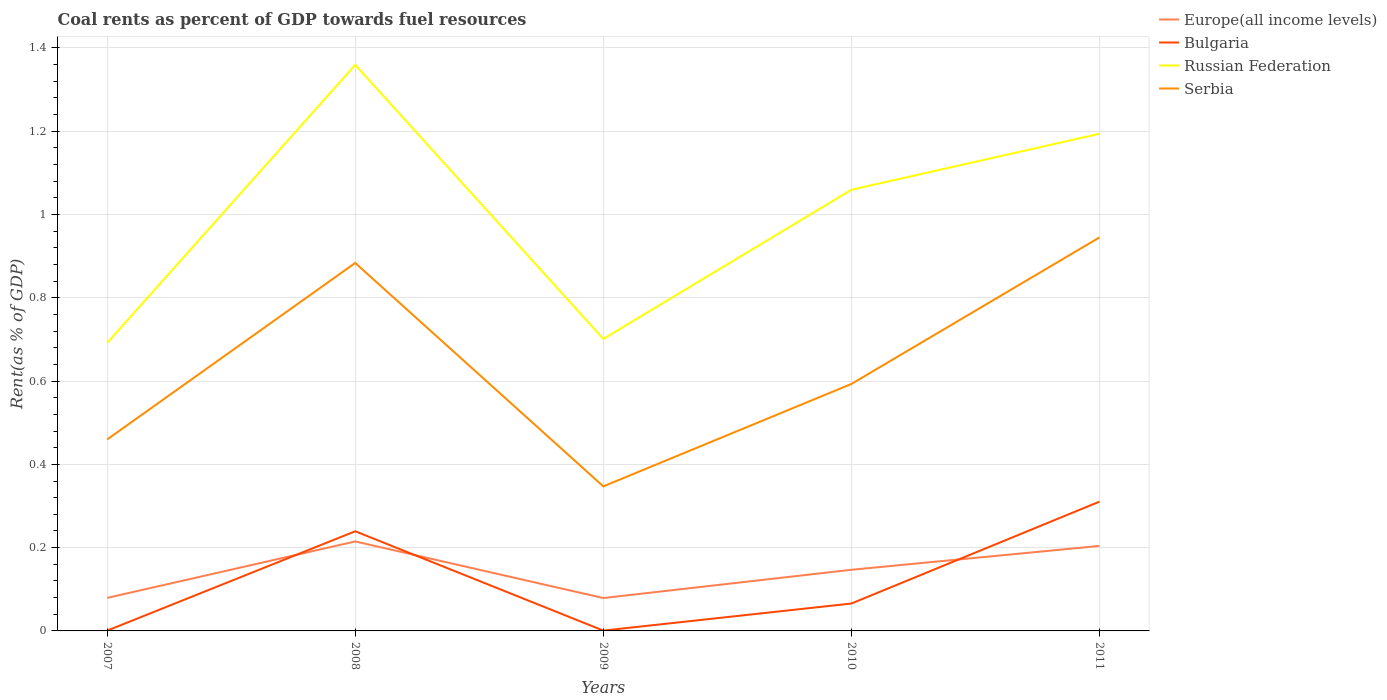How many different coloured lines are there?
Make the answer very short. 4. Is the number of lines equal to the number of legend labels?
Your response must be concise. Yes. Across all years, what is the maximum coal rent in Europe(all income levels)?
Your answer should be very brief. 0.08. In which year was the coal rent in Serbia maximum?
Offer a terse response. 2009. What is the total coal rent in Serbia in the graph?
Offer a very short reply. 0.29. What is the difference between the highest and the second highest coal rent in Serbia?
Provide a short and direct response. 0.6. Is the coal rent in Russian Federation strictly greater than the coal rent in Bulgaria over the years?
Make the answer very short. No. How many years are there in the graph?
Your response must be concise. 5. Are the values on the major ticks of Y-axis written in scientific E-notation?
Your response must be concise. No. Does the graph contain grids?
Keep it short and to the point. Yes. How are the legend labels stacked?
Offer a very short reply. Vertical. What is the title of the graph?
Give a very brief answer. Coal rents as percent of GDP towards fuel resources. Does "Maldives" appear as one of the legend labels in the graph?
Give a very brief answer. No. What is the label or title of the Y-axis?
Give a very brief answer. Rent(as % of GDP). What is the Rent(as % of GDP) in Europe(all income levels) in 2007?
Provide a short and direct response. 0.08. What is the Rent(as % of GDP) of Bulgaria in 2007?
Provide a short and direct response. 0. What is the Rent(as % of GDP) in Russian Federation in 2007?
Offer a terse response. 0.69. What is the Rent(as % of GDP) of Serbia in 2007?
Ensure brevity in your answer.  0.46. What is the Rent(as % of GDP) of Europe(all income levels) in 2008?
Provide a succinct answer. 0.21. What is the Rent(as % of GDP) of Bulgaria in 2008?
Provide a succinct answer. 0.24. What is the Rent(as % of GDP) of Russian Federation in 2008?
Provide a short and direct response. 1.36. What is the Rent(as % of GDP) of Serbia in 2008?
Your answer should be very brief. 0.88. What is the Rent(as % of GDP) of Europe(all income levels) in 2009?
Offer a terse response. 0.08. What is the Rent(as % of GDP) in Bulgaria in 2009?
Provide a succinct answer. 0. What is the Rent(as % of GDP) in Russian Federation in 2009?
Provide a short and direct response. 0.7. What is the Rent(as % of GDP) of Serbia in 2009?
Give a very brief answer. 0.35. What is the Rent(as % of GDP) in Europe(all income levels) in 2010?
Provide a short and direct response. 0.15. What is the Rent(as % of GDP) in Bulgaria in 2010?
Your response must be concise. 0.07. What is the Rent(as % of GDP) in Russian Federation in 2010?
Make the answer very short. 1.06. What is the Rent(as % of GDP) of Serbia in 2010?
Your answer should be compact. 0.59. What is the Rent(as % of GDP) in Europe(all income levels) in 2011?
Make the answer very short. 0.2. What is the Rent(as % of GDP) of Bulgaria in 2011?
Give a very brief answer. 0.31. What is the Rent(as % of GDP) of Russian Federation in 2011?
Your answer should be very brief. 1.19. What is the Rent(as % of GDP) of Serbia in 2011?
Provide a short and direct response. 0.94. Across all years, what is the maximum Rent(as % of GDP) of Europe(all income levels)?
Give a very brief answer. 0.21. Across all years, what is the maximum Rent(as % of GDP) of Bulgaria?
Ensure brevity in your answer.  0.31. Across all years, what is the maximum Rent(as % of GDP) of Russian Federation?
Your response must be concise. 1.36. Across all years, what is the maximum Rent(as % of GDP) of Serbia?
Provide a short and direct response. 0.94. Across all years, what is the minimum Rent(as % of GDP) in Europe(all income levels)?
Offer a very short reply. 0.08. Across all years, what is the minimum Rent(as % of GDP) of Bulgaria?
Your answer should be very brief. 0. Across all years, what is the minimum Rent(as % of GDP) of Russian Federation?
Keep it short and to the point. 0.69. Across all years, what is the minimum Rent(as % of GDP) of Serbia?
Provide a short and direct response. 0.35. What is the total Rent(as % of GDP) of Europe(all income levels) in the graph?
Give a very brief answer. 0.72. What is the total Rent(as % of GDP) of Bulgaria in the graph?
Your answer should be compact. 0.62. What is the total Rent(as % of GDP) of Russian Federation in the graph?
Your response must be concise. 5.01. What is the total Rent(as % of GDP) of Serbia in the graph?
Ensure brevity in your answer.  3.23. What is the difference between the Rent(as % of GDP) of Europe(all income levels) in 2007 and that in 2008?
Offer a very short reply. -0.14. What is the difference between the Rent(as % of GDP) of Bulgaria in 2007 and that in 2008?
Your response must be concise. -0.24. What is the difference between the Rent(as % of GDP) of Russian Federation in 2007 and that in 2008?
Your response must be concise. -0.67. What is the difference between the Rent(as % of GDP) of Serbia in 2007 and that in 2008?
Provide a short and direct response. -0.42. What is the difference between the Rent(as % of GDP) of Europe(all income levels) in 2007 and that in 2009?
Provide a short and direct response. 0. What is the difference between the Rent(as % of GDP) of Bulgaria in 2007 and that in 2009?
Give a very brief answer. -0. What is the difference between the Rent(as % of GDP) in Russian Federation in 2007 and that in 2009?
Your answer should be very brief. -0.01. What is the difference between the Rent(as % of GDP) in Serbia in 2007 and that in 2009?
Provide a succinct answer. 0.11. What is the difference between the Rent(as % of GDP) of Europe(all income levels) in 2007 and that in 2010?
Offer a very short reply. -0.07. What is the difference between the Rent(as % of GDP) of Bulgaria in 2007 and that in 2010?
Provide a short and direct response. -0.07. What is the difference between the Rent(as % of GDP) in Russian Federation in 2007 and that in 2010?
Keep it short and to the point. -0.37. What is the difference between the Rent(as % of GDP) in Serbia in 2007 and that in 2010?
Provide a succinct answer. -0.13. What is the difference between the Rent(as % of GDP) of Europe(all income levels) in 2007 and that in 2011?
Keep it short and to the point. -0.12. What is the difference between the Rent(as % of GDP) of Bulgaria in 2007 and that in 2011?
Make the answer very short. -0.31. What is the difference between the Rent(as % of GDP) in Russian Federation in 2007 and that in 2011?
Offer a terse response. -0.5. What is the difference between the Rent(as % of GDP) of Serbia in 2007 and that in 2011?
Keep it short and to the point. -0.49. What is the difference between the Rent(as % of GDP) of Europe(all income levels) in 2008 and that in 2009?
Offer a terse response. 0.14. What is the difference between the Rent(as % of GDP) in Bulgaria in 2008 and that in 2009?
Provide a succinct answer. 0.24. What is the difference between the Rent(as % of GDP) of Russian Federation in 2008 and that in 2009?
Make the answer very short. 0.66. What is the difference between the Rent(as % of GDP) in Serbia in 2008 and that in 2009?
Your response must be concise. 0.54. What is the difference between the Rent(as % of GDP) in Europe(all income levels) in 2008 and that in 2010?
Give a very brief answer. 0.07. What is the difference between the Rent(as % of GDP) of Bulgaria in 2008 and that in 2010?
Give a very brief answer. 0.17. What is the difference between the Rent(as % of GDP) in Serbia in 2008 and that in 2010?
Your answer should be compact. 0.29. What is the difference between the Rent(as % of GDP) of Europe(all income levels) in 2008 and that in 2011?
Keep it short and to the point. 0.01. What is the difference between the Rent(as % of GDP) in Bulgaria in 2008 and that in 2011?
Ensure brevity in your answer.  -0.07. What is the difference between the Rent(as % of GDP) of Russian Federation in 2008 and that in 2011?
Ensure brevity in your answer.  0.17. What is the difference between the Rent(as % of GDP) of Serbia in 2008 and that in 2011?
Provide a short and direct response. -0.06. What is the difference between the Rent(as % of GDP) of Europe(all income levels) in 2009 and that in 2010?
Offer a very short reply. -0.07. What is the difference between the Rent(as % of GDP) in Bulgaria in 2009 and that in 2010?
Give a very brief answer. -0.07. What is the difference between the Rent(as % of GDP) of Russian Federation in 2009 and that in 2010?
Provide a succinct answer. -0.36. What is the difference between the Rent(as % of GDP) of Serbia in 2009 and that in 2010?
Offer a very short reply. -0.25. What is the difference between the Rent(as % of GDP) in Europe(all income levels) in 2009 and that in 2011?
Offer a very short reply. -0.13. What is the difference between the Rent(as % of GDP) in Bulgaria in 2009 and that in 2011?
Provide a succinct answer. -0.31. What is the difference between the Rent(as % of GDP) in Russian Federation in 2009 and that in 2011?
Your response must be concise. -0.49. What is the difference between the Rent(as % of GDP) in Serbia in 2009 and that in 2011?
Your answer should be very brief. -0.6. What is the difference between the Rent(as % of GDP) of Europe(all income levels) in 2010 and that in 2011?
Make the answer very short. -0.06. What is the difference between the Rent(as % of GDP) in Bulgaria in 2010 and that in 2011?
Your answer should be compact. -0.24. What is the difference between the Rent(as % of GDP) of Russian Federation in 2010 and that in 2011?
Your answer should be very brief. -0.13. What is the difference between the Rent(as % of GDP) in Serbia in 2010 and that in 2011?
Make the answer very short. -0.35. What is the difference between the Rent(as % of GDP) of Europe(all income levels) in 2007 and the Rent(as % of GDP) of Bulgaria in 2008?
Make the answer very short. -0.16. What is the difference between the Rent(as % of GDP) in Europe(all income levels) in 2007 and the Rent(as % of GDP) in Russian Federation in 2008?
Provide a short and direct response. -1.28. What is the difference between the Rent(as % of GDP) of Europe(all income levels) in 2007 and the Rent(as % of GDP) of Serbia in 2008?
Offer a very short reply. -0.8. What is the difference between the Rent(as % of GDP) of Bulgaria in 2007 and the Rent(as % of GDP) of Russian Federation in 2008?
Your answer should be very brief. -1.36. What is the difference between the Rent(as % of GDP) of Bulgaria in 2007 and the Rent(as % of GDP) of Serbia in 2008?
Provide a short and direct response. -0.88. What is the difference between the Rent(as % of GDP) of Russian Federation in 2007 and the Rent(as % of GDP) of Serbia in 2008?
Your answer should be compact. -0.19. What is the difference between the Rent(as % of GDP) in Europe(all income levels) in 2007 and the Rent(as % of GDP) in Bulgaria in 2009?
Your response must be concise. 0.08. What is the difference between the Rent(as % of GDP) of Europe(all income levels) in 2007 and the Rent(as % of GDP) of Russian Federation in 2009?
Give a very brief answer. -0.62. What is the difference between the Rent(as % of GDP) of Europe(all income levels) in 2007 and the Rent(as % of GDP) of Serbia in 2009?
Provide a short and direct response. -0.27. What is the difference between the Rent(as % of GDP) in Bulgaria in 2007 and the Rent(as % of GDP) in Russian Federation in 2009?
Provide a short and direct response. -0.7. What is the difference between the Rent(as % of GDP) of Bulgaria in 2007 and the Rent(as % of GDP) of Serbia in 2009?
Make the answer very short. -0.35. What is the difference between the Rent(as % of GDP) in Russian Federation in 2007 and the Rent(as % of GDP) in Serbia in 2009?
Provide a succinct answer. 0.34. What is the difference between the Rent(as % of GDP) in Europe(all income levels) in 2007 and the Rent(as % of GDP) in Bulgaria in 2010?
Your answer should be compact. 0.01. What is the difference between the Rent(as % of GDP) of Europe(all income levels) in 2007 and the Rent(as % of GDP) of Russian Federation in 2010?
Provide a short and direct response. -0.98. What is the difference between the Rent(as % of GDP) in Europe(all income levels) in 2007 and the Rent(as % of GDP) in Serbia in 2010?
Make the answer very short. -0.51. What is the difference between the Rent(as % of GDP) in Bulgaria in 2007 and the Rent(as % of GDP) in Russian Federation in 2010?
Provide a short and direct response. -1.06. What is the difference between the Rent(as % of GDP) in Bulgaria in 2007 and the Rent(as % of GDP) in Serbia in 2010?
Give a very brief answer. -0.59. What is the difference between the Rent(as % of GDP) of Russian Federation in 2007 and the Rent(as % of GDP) of Serbia in 2010?
Your answer should be compact. 0.1. What is the difference between the Rent(as % of GDP) of Europe(all income levels) in 2007 and the Rent(as % of GDP) of Bulgaria in 2011?
Provide a short and direct response. -0.23. What is the difference between the Rent(as % of GDP) of Europe(all income levels) in 2007 and the Rent(as % of GDP) of Russian Federation in 2011?
Provide a short and direct response. -1.11. What is the difference between the Rent(as % of GDP) of Europe(all income levels) in 2007 and the Rent(as % of GDP) of Serbia in 2011?
Offer a terse response. -0.87. What is the difference between the Rent(as % of GDP) of Bulgaria in 2007 and the Rent(as % of GDP) of Russian Federation in 2011?
Ensure brevity in your answer.  -1.19. What is the difference between the Rent(as % of GDP) of Bulgaria in 2007 and the Rent(as % of GDP) of Serbia in 2011?
Your answer should be compact. -0.94. What is the difference between the Rent(as % of GDP) of Russian Federation in 2007 and the Rent(as % of GDP) of Serbia in 2011?
Offer a very short reply. -0.25. What is the difference between the Rent(as % of GDP) in Europe(all income levels) in 2008 and the Rent(as % of GDP) in Bulgaria in 2009?
Offer a very short reply. 0.21. What is the difference between the Rent(as % of GDP) in Europe(all income levels) in 2008 and the Rent(as % of GDP) in Russian Federation in 2009?
Offer a terse response. -0.49. What is the difference between the Rent(as % of GDP) of Europe(all income levels) in 2008 and the Rent(as % of GDP) of Serbia in 2009?
Provide a short and direct response. -0.13. What is the difference between the Rent(as % of GDP) of Bulgaria in 2008 and the Rent(as % of GDP) of Russian Federation in 2009?
Provide a succinct answer. -0.46. What is the difference between the Rent(as % of GDP) in Bulgaria in 2008 and the Rent(as % of GDP) in Serbia in 2009?
Give a very brief answer. -0.11. What is the difference between the Rent(as % of GDP) of Russian Federation in 2008 and the Rent(as % of GDP) of Serbia in 2009?
Your answer should be very brief. 1.01. What is the difference between the Rent(as % of GDP) of Europe(all income levels) in 2008 and the Rent(as % of GDP) of Bulgaria in 2010?
Keep it short and to the point. 0.15. What is the difference between the Rent(as % of GDP) in Europe(all income levels) in 2008 and the Rent(as % of GDP) in Russian Federation in 2010?
Offer a very short reply. -0.84. What is the difference between the Rent(as % of GDP) in Europe(all income levels) in 2008 and the Rent(as % of GDP) in Serbia in 2010?
Offer a terse response. -0.38. What is the difference between the Rent(as % of GDP) in Bulgaria in 2008 and the Rent(as % of GDP) in Russian Federation in 2010?
Your response must be concise. -0.82. What is the difference between the Rent(as % of GDP) of Bulgaria in 2008 and the Rent(as % of GDP) of Serbia in 2010?
Provide a short and direct response. -0.35. What is the difference between the Rent(as % of GDP) in Russian Federation in 2008 and the Rent(as % of GDP) in Serbia in 2010?
Keep it short and to the point. 0.77. What is the difference between the Rent(as % of GDP) of Europe(all income levels) in 2008 and the Rent(as % of GDP) of Bulgaria in 2011?
Give a very brief answer. -0.1. What is the difference between the Rent(as % of GDP) of Europe(all income levels) in 2008 and the Rent(as % of GDP) of Russian Federation in 2011?
Your response must be concise. -0.98. What is the difference between the Rent(as % of GDP) in Europe(all income levels) in 2008 and the Rent(as % of GDP) in Serbia in 2011?
Keep it short and to the point. -0.73. What is the difference between the Rent(as % of GDP) in Bulgaria in 2008 and the Rent(as % of GDP) in Russian Federation in 2011?
Offer a terse response. -0.95. What is the difference between the Rent(as % of GDP) in Bulgaria in 2008 and the Rent(as % of GDP) in Serbia in 2011?
Provide a short and direct response. -0.71. What is the difference between the Rent(as % of GDP) in Russian Federation in 2008 and the Rent(as % of GDP) in Serbia in 2011?
Your answer should be compact. 0.41. What is the difference between the Rent(as % of GDP) of Europe(all income levels) in 2009 and the Rent(as % of GDP) of Bulgaria in 2010?
Your response must be concise. 0.01. What is the difference between the Rent(as % of GDP) in Europe(all income levels) in 2009 and the Rent(as % of GDP) in Russian Federation in 2010?
Your answer should be very brief. -0.98. What is the difference between the Rent(as % of GDP) in Europe(all income levels) in 2009 and the Rent(as % of GDP) in Serbia in 2010?
Give a very brief answer. -0.51. What is the difference between the Rent(as % of GDP) in Bulgaria in 2009 and the Rent(as % of GDP) in Russian Federation in 2010?
Offer a terse response. -1.06. What is the difference between the Rent(as % of GDP) in Bulgaria in 2009 and the Rent(as % of GDP) in Serbia in 2010?
Give a very brief answer. -0.59. What is the difference between the Rent(as % of GDP) of Russian Federation in 2009 and the Rent(as % of GDP) of Serbia in 2010?
Offer a terse response. 0.11. What is the difference between the Rent(as % of GDP) of Europe(all income levels) in 2009 and the Rent(as % of GDP) of Bulgaria in 2011?
Your answer should be compact. -0.23. What is the difference between the Rent(as % of GDP) of Europe(all income levels) in 2009 and the Rent(as % of GDP) of Russian Federation in 2011?
Make the answer very short. -1.11. What is the difference between the Rent(as % of GDP) of Europe(all income levels) in 2009 and the Rent(as % of GDP) of Serbia in 2011?
Keep it short and to the point. -0.87. What is the difference between the Rent(as % of GDP) of Bulgaria in 2009 and the Rent(as % of GDP) of Russian Federation in 2011?
Make the answer very short. -1.19. What is the difference between the Rent(as % of GDP) of Bulgaria in 2009 and the Rent(as % of GDP) of Serbia in 2011?
Offer a terse response. -0.94. What is the difference between the Rent(as % of GDP) of Russian Federation in 2009 and the Rent(as % of GDP) of Serbia in 2011?
Your answer should be compact. -0.24. What is the difference between the Rent(as % of GDP) of Europe(all income levels) in 2010 and the Rent(as % of GDP) of Bulgaria in 2011?
Give a very brief answer. -0.16. What is the difference between the Rent(as % of GDP) of Europe(all income levels) in 2010 and the Rent(as % of GDP) of Russian Federation in 2011?
Your answer should be very brief. -1.05. What is the difference between the Rent(as % of GDP) of Europe(all income levels) in 2010 and the Rent(as % of GDP) of Serbia in 2011?
Provide a short and direct response. -0.8. What is the difference between the Rent(as % of GDP) in Bulgaria in 2010 and the Rent(as % of GDP) in Russian Federation in 2011?
Offer a very short reply. -1.13. What is the difference between the Rent(as % of GDP) in Bulgaria in 2010 and the Rent(as % of GDP) in Serbia in 2011?
Offer a very short reply. -0.88. What is the difference between the Rent(as % of GDP) in Russian Federation in 2010 and the Rent(as % of GDP) in Serbia in 2011?
Make the answer very short. 0.11. What is the average Rent(as % of GDP) in Europe(all income levels) per year?
Your response must be concise. 0.14. What is the average Rent(as % of GDP) of Bulgaria per year?
Provide a succinct answer. 0.12. What is the average Rent(as % of GDP) of Serbia per year?
Give a very brief answer. 0.65. In the year 2007, what is the difference between the Rent(as % of GDP) of Europe(all income levels) and Rent(as % of GDP) of Bulgaria?
Your answer should be very brief. 0.08. In the year 2007, what is the difference between the Rent(as % of GDP) in Europe(all income levels) and Rent(as % of GDP) in Russian Federation?
Ensure brevity in your answer.  -0.61. In the year 2007, what is the difference between the Rent(as % of GDP) in Europe(all income levels) and Rent(as % of GDP) in Serbia?
Your answer should be very brief. -0.38. In the year 2007, what is the difference between the Rent(as % of GDP) in Bulgaria and Rent(as % of GDP) in Russian Federation?
Ensure brevity in your answer.  -0.69. In the year 2007, what is the difference between the Rent(as % of GDP) of Bulgaria and Rent(as % of GDP) of Serbia?
Your answer should be very brief. -0.46. In the year 2007, what is the difference between the Rent(as % of GDP) in Russian Federation and Rent(as % of GDP) in Serbia?
Give a very brief answer. 0.23. In the year 2008, what is the difference between the Rent(as % of GDP) in Europe(all income levels) and Rent(as % of GDP) in Bulgaria?
Your response must be concise. -0.02. In the year 2008, what is the difference between the Rent(as % of GDP) of Europe(all income levels) and Rent(as % of GDP) of Russian Federation?
Provide a succinct answer. -1.14. In the year 2008, what is the difference between the Rent(as % of GDP) of Europe(all income levels) and Rent(as % of GDP) of Serbia?
Give a very brief answer. -0.67. In the year 2008, what is the difference between the Rent(as % of GDP) of Bulgaria and Rent(as % of GDP) of Russian Federation?
Keep it short and to the point. -1.12. In the year 2008, what is the difference between the Rent(as % of GDP) of Bulgaria and Rent(as % of GDP) of Serbia?
Your answer should be very brief. -0.64. In the year 2008, what is the difference between the Rent(as % of GDP) in Russian Federation and Rent(as % of GDP) in Serbia?
Provide a succinct answer. 0.48. In the year 2009, what is the difference between the Rent(as % of GDP) of Europe(all income levels) and Rent(as % of GDP) of Bulgaria?
Your answer should be very brief. 0.08. In the year 2009, what is the difference between the Rent(as % of GDP) of Europe(all income levels) and Rent(as % of GDP) of Russian Federation?
Give a very brief answer. -0.62. In the year 2009, what is the difference between the Rent(as % of GDP) of Europe(all income levels) and Rent(as % of GDP) of Serbia?
Offer a terse response. -0.27. In the year 2009, what is the difference between the Rent(as % of GDP) of Bulgaria and Rent(as % of GDP) of Russian Federation?
Your response must be concise. -0.7. In the year 2009, what is the difference between the Rent(as % of GDP) in Bulgaria and Rent(as % of GDP) in Serbia?
Make the answer very short. -0.35. In the year 2009, what is the difference between the Rent(as % of GDP) of Russian Federation and Rent(as % of GDP) of Serbia?
Make the answer very short. 0.35. In the year 2010, what is the difference between the Rent(as % of GDP) in Europe(all income levels) and Rent(as % of GDP) in Bulgaria?
Your answer should be very brief. 0.08. In the year 2010, what is the difference between the Rent(as % of GDP) of Europe(all income levels) and Rent(as % of GDP) of Russian Federation?
Keep it short and to the point. -0.91. In the year 2010, what is the difference between the Rent(as % of GDP) of Europe(all income levels) and Rent(as % of GDP) of Serbia?
Your answer should be very brief. -0.45. In the year 2010, what is the difference between the Rent(as % of GDP) of Bulgaria and Rent(as % of GDP) of Russian Federation?
Your answer should be compact. -0.99. In the year 2010, what is the difference between the Rent(as % of GDP) of Bulgaria and Rent(as % of GDP) of Serbia?
Your answer should be compact. -0.53. In the year 2010, what is the difference between the Rent(as % of GDP) of Russian Federation and Rent(as % of GDP) of Serbia?
Provide a succinct answer. 0.47. In the year 2011, what is the difference between the Rent(as % of GDP) in Europe(all income levels) and Rent(as % of GDP) in Bulgaria?
Provide a succinct answer. -0.11. In the year 2011, what is the difference between the Rent(as % of GDP) in Europe(all income levels) and Rent(as % of GDP) in Russian Federation?
Your answer should be compact. -0.99. In the year 2011, what is the difference between the Rent(as % of GDP) of Europe(all income levels) and Rent(as % of GDP) of Serbia?
Keep it short and to the point. -0.74. In the year 2011, what is the difference between the Rent(as % of GDP) in Bulgaria and Rent(as % of GDP) in Russian Federation?
Your response must be concise. -0.88. In the year 2011, what is the difference between the Rent(as % of GDP) of Bulgaria and Rent(as % of GDP) of Serbia?
Provide a short and direct response. -0.63. In the year 2011, what is the difference between the Rent(as % of GDP) in Russian Federation and Rent(as % of GDP) in Serbia?
Offer a very short reply. 0.25. What is the ratio of the Rent(as % of GDP) of Europe(all income levels) in 2007 to that in 2008?
Give a very brief answer. 0.37. What is the ratio of the Rent(as % of GDP) of Bulgaria in 2007 to that in 2008?
Provide a succinct answer. 0. What is the ratio of the Rent(as % of GDP) in Russian Federation in 2007 to that in 2008?
Make the answer very short. 0.51. What is the ratio of the Rent(as % of GDP) in Serbia in 2007 to that in 2008?
Offer a very short reply. 0.52. What is the ratio of the Rent(as % of GDP) in Europe(all income levels) in 2007 to that in 2009?
Provide a succinct answer. 1. What is the ratio of the Rent(as % of GDP) in Bulgaria in 2007 to that in 2009?
Keep it short and to the point. 0.88. What is the ratio of the Rent(as % of GDP) in Russian Federation in 2007 to that in 2009?
Your answer should be compact. 0.99. What is the ratio of the Rent(as % of GDP) of Serbia in 2007 to that in 2009?
Make the answer very short. 1.32. What is the ratio of the Rent(as % of GDP) of Europe(all income levels) in 2007 to that in 2010?
Your answer should be compact. 0.54. What is the ratio of the Rent(as % of GDP) in Bulgaria in 2007 to that in 2010?
Your answer should be compact. 0.01. What is the ratio of the Rent(as % of GDP) in Russian Federation in 2007 to that in 2010?
Give a very brief answer. 0.65. What is the ratio of the Rent(as % of GDP) in Serbia in 2007 to that in 2010?
Offer a very short reply. 0.78. What is the ratio of the Rent(as % of GDP) in Europe(all income levels) in 2007 to that in 2011?
Your answer should be compact. 0.39. What is the ratio of the Rent(as % of GDP) of Bulgaria in 2007 to that in 2011?
Make the answer very short. 0. What is the ratio of the Rent(as % of GDP) of Russian Federation in 2007 to that in 2011?
Keep it short and to the point. 0.58. What is the ratio of the Rent(as % of GDP) in Serbia in 2007 to that in 2011?
Offer a very short reply. 0.49. What is the ratio of the Rent(as % of GDP) of Europe(all income levels) in 2008 to that in 2009?
Provide a succinct answer. 2.72. What is the ratio of the Rent(as % of GDP) of Bulgaria in 2008 to that in 2009?
Keep it short and to the point. 295.92. What is the ratio of the Rent(as % of GDP) of Russian Federation in 2008 to that in 2009?
Provide a succinct answer. 1.94. What is the ratio of the Rent(as % of GDP) of Serbia in 2008 to that in 2009?
Your response must be concise. 2.55. What is the ratio of the Rent(as % of GDP) in Europe(all income levels) in 2008 to that in 2010?
Your answer should be compact. 1.46. What is the ratio of the Rent(as % of GDP) in Bulgaria in 2008 to that in 2010?
Provide a short and direct response. 3.64. What is the ratio of the Rent(as % of GDP) of Russian Federation in 2008 to that in 2010?
Offer a terse response. 1.28. What is the ratio of the Rent(as % of GDP) of Serbia in 2008 to that in 2010?
Ensure brevity in your answer.  1.49. What is the ratio of the Rent(as % of GDP) in Europe(all income levels) in 2008 to that in 2011?
Make the answer very short. 1.05. What is the ratio of the Rent(as % of GDP) of Bulgaria in 2008 to that in 2011?
Provide a succinct answer. 0.77. What is the ratio of the Rent(as % of GDP) in Russian Federation in 2008 to that in 2011?
Ensure brevity in your answer.  1.14. What is the ratio of the Rent(as % of GDP) of Serbia in 2008 to that in 2011?
Make the answer very short. 0.94. What is the ratio of the Rent(as % of GDP) of Europe(all income levels) in 2009 to that in 2010?
Provide a succinct answer. 0.54. What is the ratio of the Rent(as % of GDP) of Bulgaria in 2009 to that in 2010?
Your response must be concise. 0.01. What is the ratio of the Rent(as % of GDP) in Russian Federation in 2009 to that in 2010?
Ensure brevity in your answer.  0.66. What is the ratio of the Rent(as % of GDP) in Serbia in 2009 to that in 2010?
Make the answer very short. 0.59. What is the ratio of the Rent(as % of GDP) in Europe(all income levels) in 2009 to that in 2011?
Your response must be concise. 0.39. What is the ratio of the Rent(as % of GDP) in Bulgaria in 2009 to that in 2011?
Make the answer very short. 0. What is the ratio of the Rent(as % of GDP) in Russian Federation in 2009 to that in 2011?
Your answer should be very brief. 0.59. What is the ratio of the Rent(as % of GDP) of Serbia in 2009 to that in 2011?
Provide a succinct answer. 0.37. What is the ratio of the Rent(as % of GDP) in Europe(all income levels) in 2010 to that in 2011?
Offer a terse response. 0.72. What is the ratio of the Rent(as % of GDP) in Bulgaria in 2010 to that in 2011?
Make the answer very short. 0.21. What is the ratio of the Rent(as % of GDP) in Russian Federation in 2010 to that in 2011?
Your response must be concise. 0.89. What is the ratio of the Rent(as % of GDP) in Serbia in 2010 to that in 2011?
Your response must be concise. 0.63. What is the difference between the highest and the second highest Rent(as % of GDP) of Europe(all income levels)?
Offer a terse response. 0.01. What is the difference between the highest and the second highest Rent(as % of GDP) of Bulgaria?
Your answer should be very brief. 0.07. What is the difference between the highest and the second highest Rent(as % of GDP) in Russian Federation?
Your answer should be compact. 0.17. What is the difference between the highest and the second highest Rent(as % of GDP) of Serbia?
Provide a short and direct response. 0.06. What is the difference between the highest and the lowest Rent(as % of GDP) of Europe(all income levels)?
Offer a terse response. 0.14. What is the difference between the highest and the lowest Rent(as % of GDP) of Bulgaria?
Offer a terse response. 0.31. What is the difference between the highest and the lowest Rent(as % of GDP) of Russian Federation?
Make the answer very short. 0.67. What is the difference between the highest and the lowest Rent(as % of GDP) of Serbia?
Your answer should be compact. 0.6. 